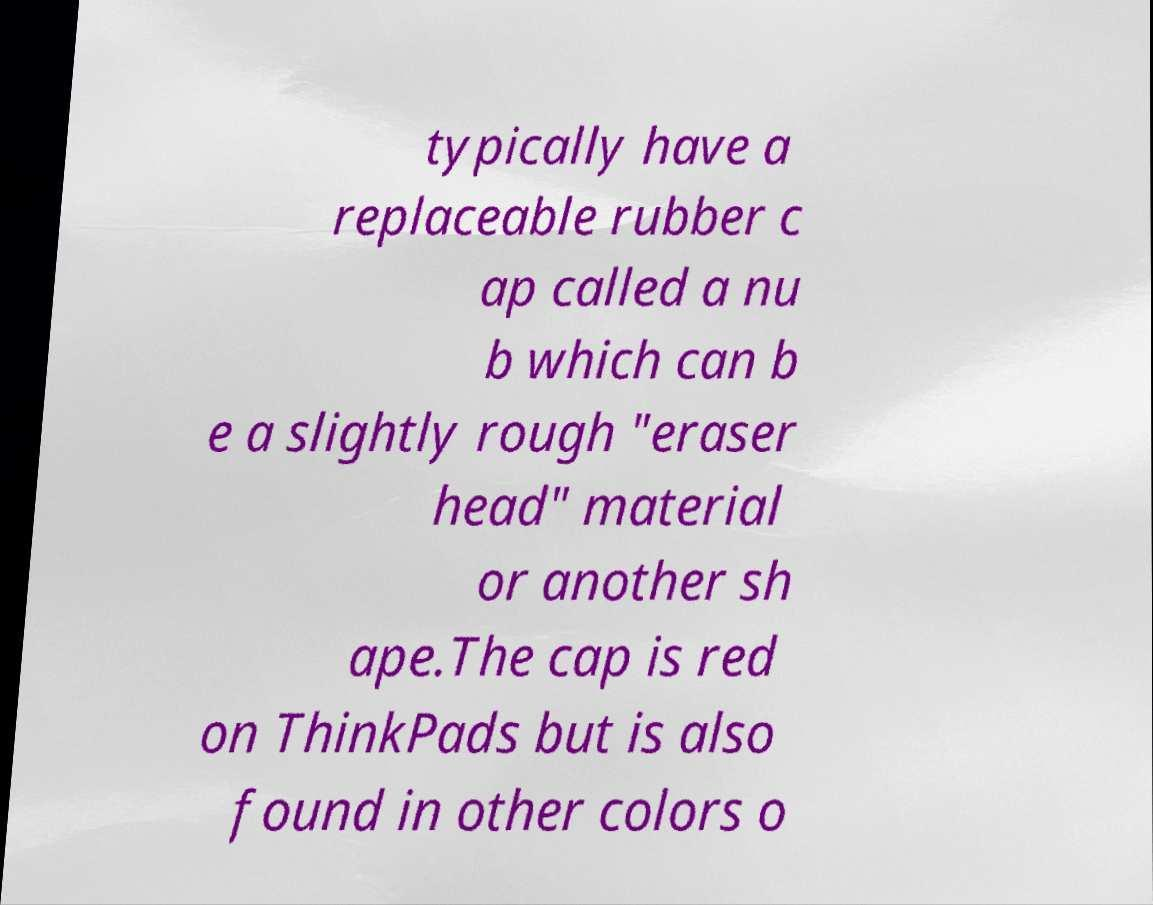Please identify and transcribe the text found in this image. typically have a replaceable rubber c ap called a nu b which can b e a slightly rough "eraser head" material or another sh ape.The cap is red on ThinkPads but is also found in other colors o 